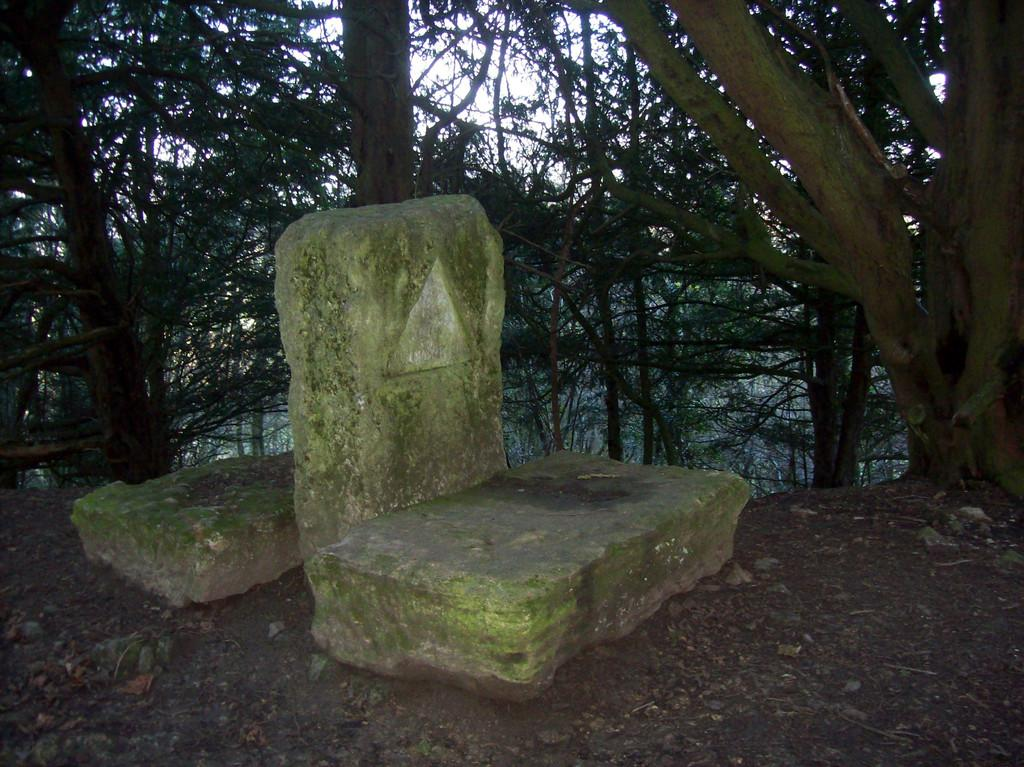How many stones can be seen in the image? There are three stones in the image. Is there anything unique about one of the stones? Yes, one of the stones has a triangular shape on it. What can be seen in the background of the image? There are trees visible in the background of the image. What type of breakfast is being served on the stones in the image? There is no breakfast present in the image; it only features three stones, one of which has a triangular shape on it, and trees in the background. 